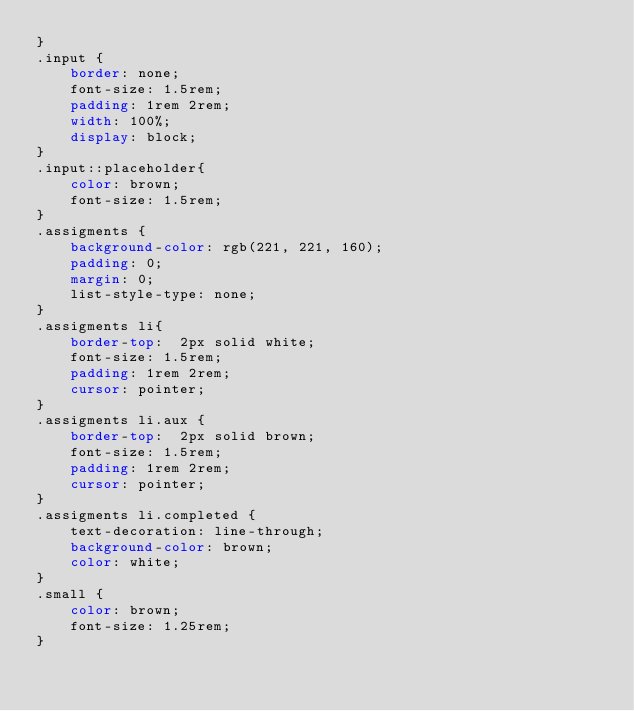Convert code to text. <code><loc_0><loc_0><loc_500><loc_500><_CSS_>}
.input {
    border: none;
    font-size: 1.5rem;
    padding: 1rem 2rem;
    width: 100%;
    display: block;
}
.input::placeholder{
    color: brown;
    font-size: 1.5rem;
}
.assigments {
    background-color: rgb(221, 221, 160);
    padding: 0;
    margin: 0;
    list-style-type: none;
}
.assigments li{
    border-top:  2px solid white;
    font-size: 1.5rem;
    padding: 1rem 2rem;
    cursor: pointer;
}
.assigments li.aux {
    border-top:  2px solid brown;
    font-size: 1.5rem;
    padding: 1rem 2rem;
    cursor: pointer;
}
.assigments li.completed {
    text-decoration: line-through;
    background-color: brown;
    color: white;
}
.small {
    color: brown;
    font-size: 1.25rem;
}</code> 